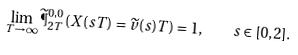<formula> <loc_0><loc_0><loc_500><loc_500>\lim _ { T \to \infty } \widetilde { \P } ^ { 0 , 0 } _ { 2 T } ( X ( s T ) = \widetilde { v } ( s ) T ) = 1 , \quad s \in [ 0 , 2 ] .</formula> 